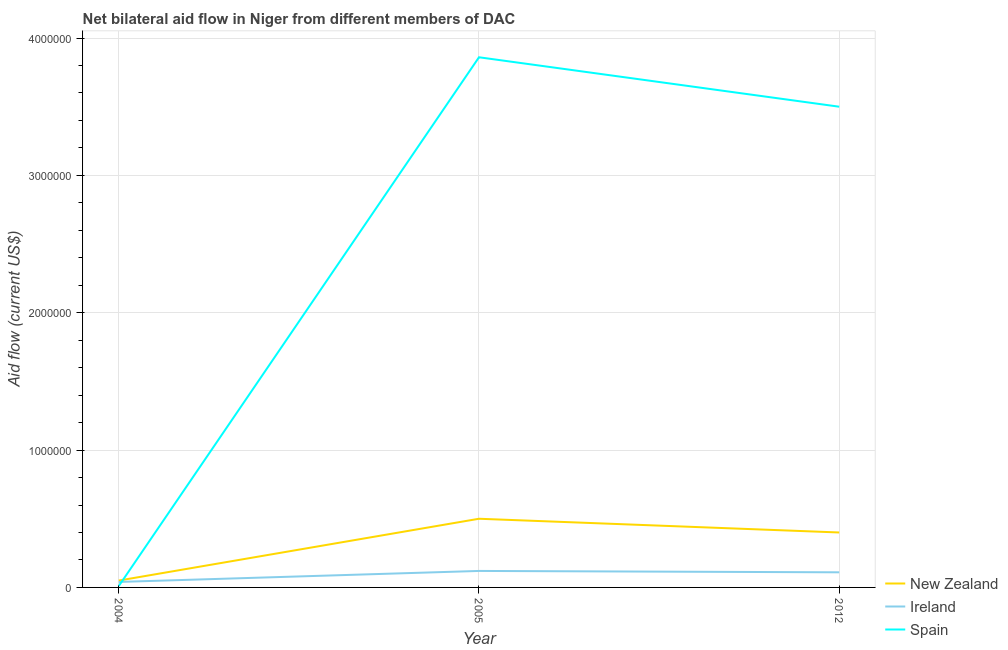How many different coloured lines are there?
Your answer should be compact. 3. Does the line corresponding to amount of aid provided by spain intersect with the line corresponding to amount of aid provided by ireland?
Your answer should be compact. Yes. What is the amount of aid provided by new zealand in 2004?
Keep it short and to the point. 5.00e+04. Across all years, what is the maximum amount of aid provided by spain?
Give a very brief answer. 3.86e+06. Across all years, what is the minimum amount of aid provided by spain?
Provide a succinct answer. 10000. What is the total amount of aid provided by ireland in the graph?
Provide a succinct answer. 2.70e+05. What is the difference between the amount of aid provided by new zealand in 2004 and that in 2012?
Ensure brevity in your answer.  -3.50e+05. What is the difference between the amount of aid provided by spain in 2012 and the amount of aid provided by new zealand in 2004?
Your answer should be compact. 3.45e+06. What is the average amount of aid provided by spain per year?
Offer a very short reply. 2.46e+06. In the year 2005, what is the difference between the amount of aid provided by ireland and amount of aid provided by spain?
Your response must be concise. -3.74e+06. In how many years, is the amount of aid provided by ireland greater than 3400000 US$?
Make the answer very short. 0. What is the ratio of the amount of aid provided by spain in 2005 to that in 2012?
Offer a very short reply. 1.1. Is the difference between the amount of aid provided by new zealand in 2005 and 2012 greater than the difference between the amount of aid provided by ireland in 2005 and 2012?
Your answer should be compact. Yes. What is the difference between the highest and the second highest amount of aid provided by new zealand?
Provide a short and direct response. 1.00e+05. What is the difference between the highest and the lowest amount of aid provided by spain?
Provide a succinct answer. 3.85e+06. Is the sum of the amount of aid provided by spain in 2005 and 2012 greater than the maximum amount of aid provided by new zealand across all years?
Ensure brevity in your answer.  Yes. Is the amount of aid provided by ireland strictly greater than the amount of aid provided by new zealand over the years?
Your answer should be compact. No. How many years are there in the graph?
Ensure brevity in your answer.  3. Does the graph contain any zero values?
Give a very brief answer. No. Where does the legend appear in the graph?
Your response must be concise. Bottom right. How are the legend labels stacked?
Offer a terse response. Vertical. What is the title of the graph?
Your response must be concise. Net bilateral aid flow in Niger from different members of DAC. Does "Ages 15-20" appear as one of the legend labels in the graph?
Offer a very short reply. No. What is the label or title of the X-axis?
Your response must be concise. Year. What is the label or title of the Y-axis?
Provide a succinct answer. Aid flow (current US$). What is the Aid flow (current US$) of Ireland in 2004?
Your response must be concise. 4.00e+04. What is the Aid flow (current US$) of Ireland in 2005?
Keep it short and to the point. 1.20e+05. What is the Aid flow (current US$) of Spain in 2005?
Your response must be concise. 3.86e+06. What is the Aid flow (current US$) of Ireland in 2012?
Make the answer very short. 1.10e+05. What is the Aid flow (current US$) of Spain in 2012?
Ensure brevity in your answer.  3.50e+06. Across all years, what is the maximum Aid flow (current US$) of Ireland?
Keep it short and to the point. 1.20e+05. Across all years, what is the maximum Aid flow (current US$) in Spain?
Ensure brevity in your answer.  3.86e+06. Across all years, what is the minimum Aid flow (current US$) in New Zealand?
Provide a succinct answer. 5.00e+04. Across all years, what is the minimum Aid flow (current US$) in Ireland?
Your answer should be very brief. 4.00e+04. Across all years, what is the minimum Aid flow (current US$) of Spain?
Make the answer very short. 10000. What is the total Aid flow (current US$) in New Zealand in the graph?
Your answer should be very brief. 9.50e+05. What is the total Aid flow (current US$) of Spain in the graph?
Provide a short and direct response. 7.37e+06. What is the difference between the Aid flow (current US$) of New Zealand in 2004 and that in 2005?
Your answer should be very brief. -4.50e+05. What is the difference between the Aid flow (current US$) in Spain in 2004 and that in 2005?
Your response must be concise. -3.85e+06. What is the difference between the Aid flow (current US$) in New Zealand in 2004 and that in 2012?
Your answer should be very brief. -3.50e+05. What is the difference between the Aid flow (current US$) of Ireland in 2004 and that in 2012?
Keep it short and to the point. -7.00e+04. What is the difference between the Aid flow (current US$) in Spain in 2004 and that in 2012?
Provide a short and direct response. -3.49e+06. What is the difference between the Aid flow (current US$) in New Zealand in 2005 and that in 2012?
Provide a short and direct response. 1.00e+05. What is the difference between the Aid flow (current US$) of Ireland in 2005 and that in 2012?
Provide a succinct answer. 10000. What is the difference between the Aid flow (current US$) in Spain in 2005 and that in 2012?
Give a very brief answer. 3.60e+05. What is the difference between the Aid flow (current US$) of New Zealand in 2004 and the Aid flow (current US$) of Ireland in 2005?
Offer a terse response. -7.00e+04. What is the difference between the Aid flow (current US$) in New Zealand in 2004 and the Aid flow (current US$) in Spain in 2005?
Your response must be concise. -3.81e+06. What is the difference between the Aid flow (current US$) in Ireland in 2004 and the Aid flow (current US$) in Spain in 2005?
Provide a short and direct response. -3.82e+06. What is the difference between the Aid flow (current US$) of New Zealand in 2004 and the Aid flow (current US$) of Ireland in 2012?
Your response must be concise. -6.00e+04. What is the difference between the Aid flow (current US$) of New Zealand in 2004 and the Aid flow (current US$) of Spain in 2012?
Your answer should be compact. -3.45e+06. What is the difference between the Aid flow (current US$) of Ireland in 2004 and the Aid flow (current US$) of Spain in 2012?
Your answer should be very brief. -3.46e+06. What is the difference between the Aid flow (current US$) in New Zealand in 2005 and the Aid flow (current US$) in Spain in 2012?
Your answer should be compact. -3.00e+06. What is the difference between the Aid flow (current US$) in Ireland in 2005 and the Aid flow (current US$) in Spain in 2012?
Your response must be concise. -3.38e+06. What is the average Aid flow (current US$) in New Zealand per year?
Make the answer very short. 3.17e+05. What is the average Aid flow (current US$) of Spain per year?
Keep it short and to the point. 2.46e+06. In the year 2004, what is the difference between the Aid flow (current US$) in New Zealand and Aid flow (current US$) in Spain?
Make the answer very short. 4.00e+04. In the year 2005, what is the difference between the Aid flow (current US$) in New Zealand and Aid flow (current US$) in Ireland?
Offer a terse response. 3.80e+05. In the year 2005, what is the difference between the Aid flow (current US$) of New Zealand and Aid flow (current US$) of Spain?
Give a very brief answer. -3.36e+06. In the year 2005, what is the difference between the Aid flow (current US$) in Ireland and Aid flow (current US$) in Spain?
Ensure brevity in your answer.  -3.74e+06. In the year 2012, what is the difference between the Aid flow (current US$) of New Zealand and Aid flow (current US$) of Spain?
Keep it short and to the point. -3.10e+06. In the year 2012, what is the difference between the Aid flow (current US$) in Ireland and Aid flow (current US$) in Spain?
Ensure brevity in your answer.  -3.39e+06. What is the ratio of the Aid flow (current US$) in New Zealand in 2004 to that in 2005?
Your answer should be very brief. 0.1. What is the ratio of the Aid flow (current US$) in Spain in 2004 to that in 2005?
Your response must be concise. 0. What is the ratio of the Aid flow (current US$) in Ireland in 2004 to that in 2012?
Ensure brevity in your answer.  0.36. What is the ratio of the Aid flow (current US$) in Spain in 2004 to that in 2012?
Ensure brevity in your answer.  0. What is the ratio of the Aid flow (current US$) of Spain in 2005 to that in 2012?
Offer a terse response. 1.1. What is the difference between the highest and the second highest Aid flow (current US$) in New Zealand?
Your answer should be very brief. 1.00e+05. What is the difference between the highest and the lowest Aid flow (current US$) of Spain?
Offer a very short reply. 3.85e+06. 